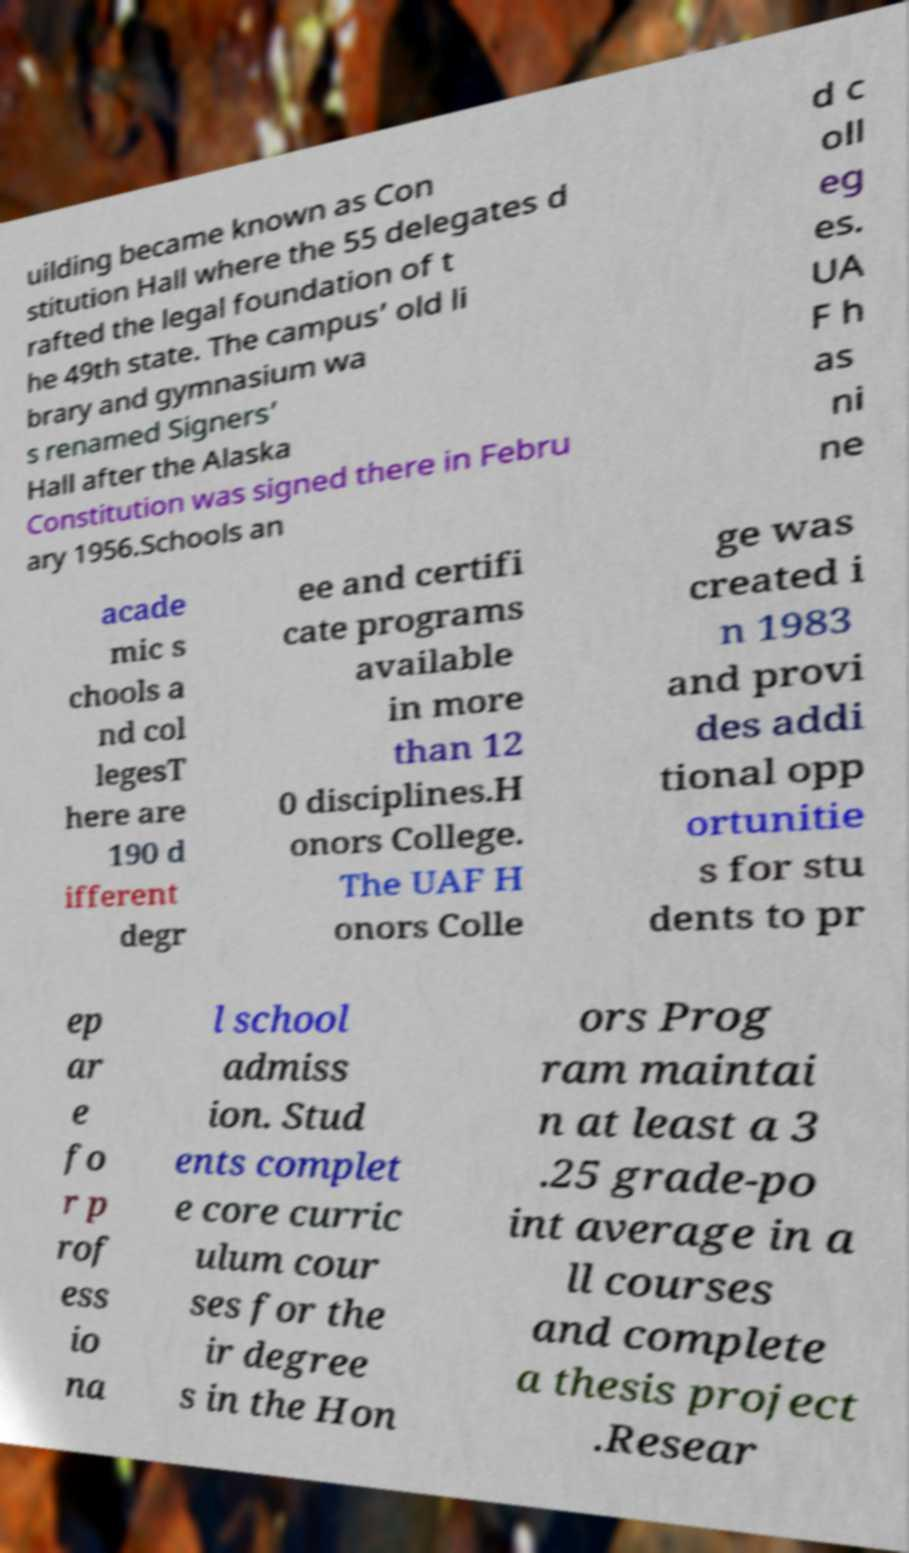What messages or text are displayed in this image? I need them in a readable, typed format. uilding became known as Con stitution Hall where the 55 delegates d rafted the legal foundation of t he 49th state. The campus’ old li brary and gymnasium wa s renamed Signers’ Hall after the Alaska Constitution was signed there in Febru ary 1956.Schools an d c oll eg es. UA F h as ni ne acade mic s chools a nd col legesT here are 190 d ifferent degr ee and certifi cate programs available in more than 12 0 disciplines.H onors College. The UAF H onors Colle ge was created i n 1983 and provi des addi tional opp ortunitie s for stu dents to pr ep ar e fo r p rof ess io na l school admiss ion. Stud ents complet e core curric ulum cour ses for the ir degree s in the Hon ors Prog ram maintai n at least a 3 .25 grade-po int average in a ll courses and complete a thesis project .Resear 